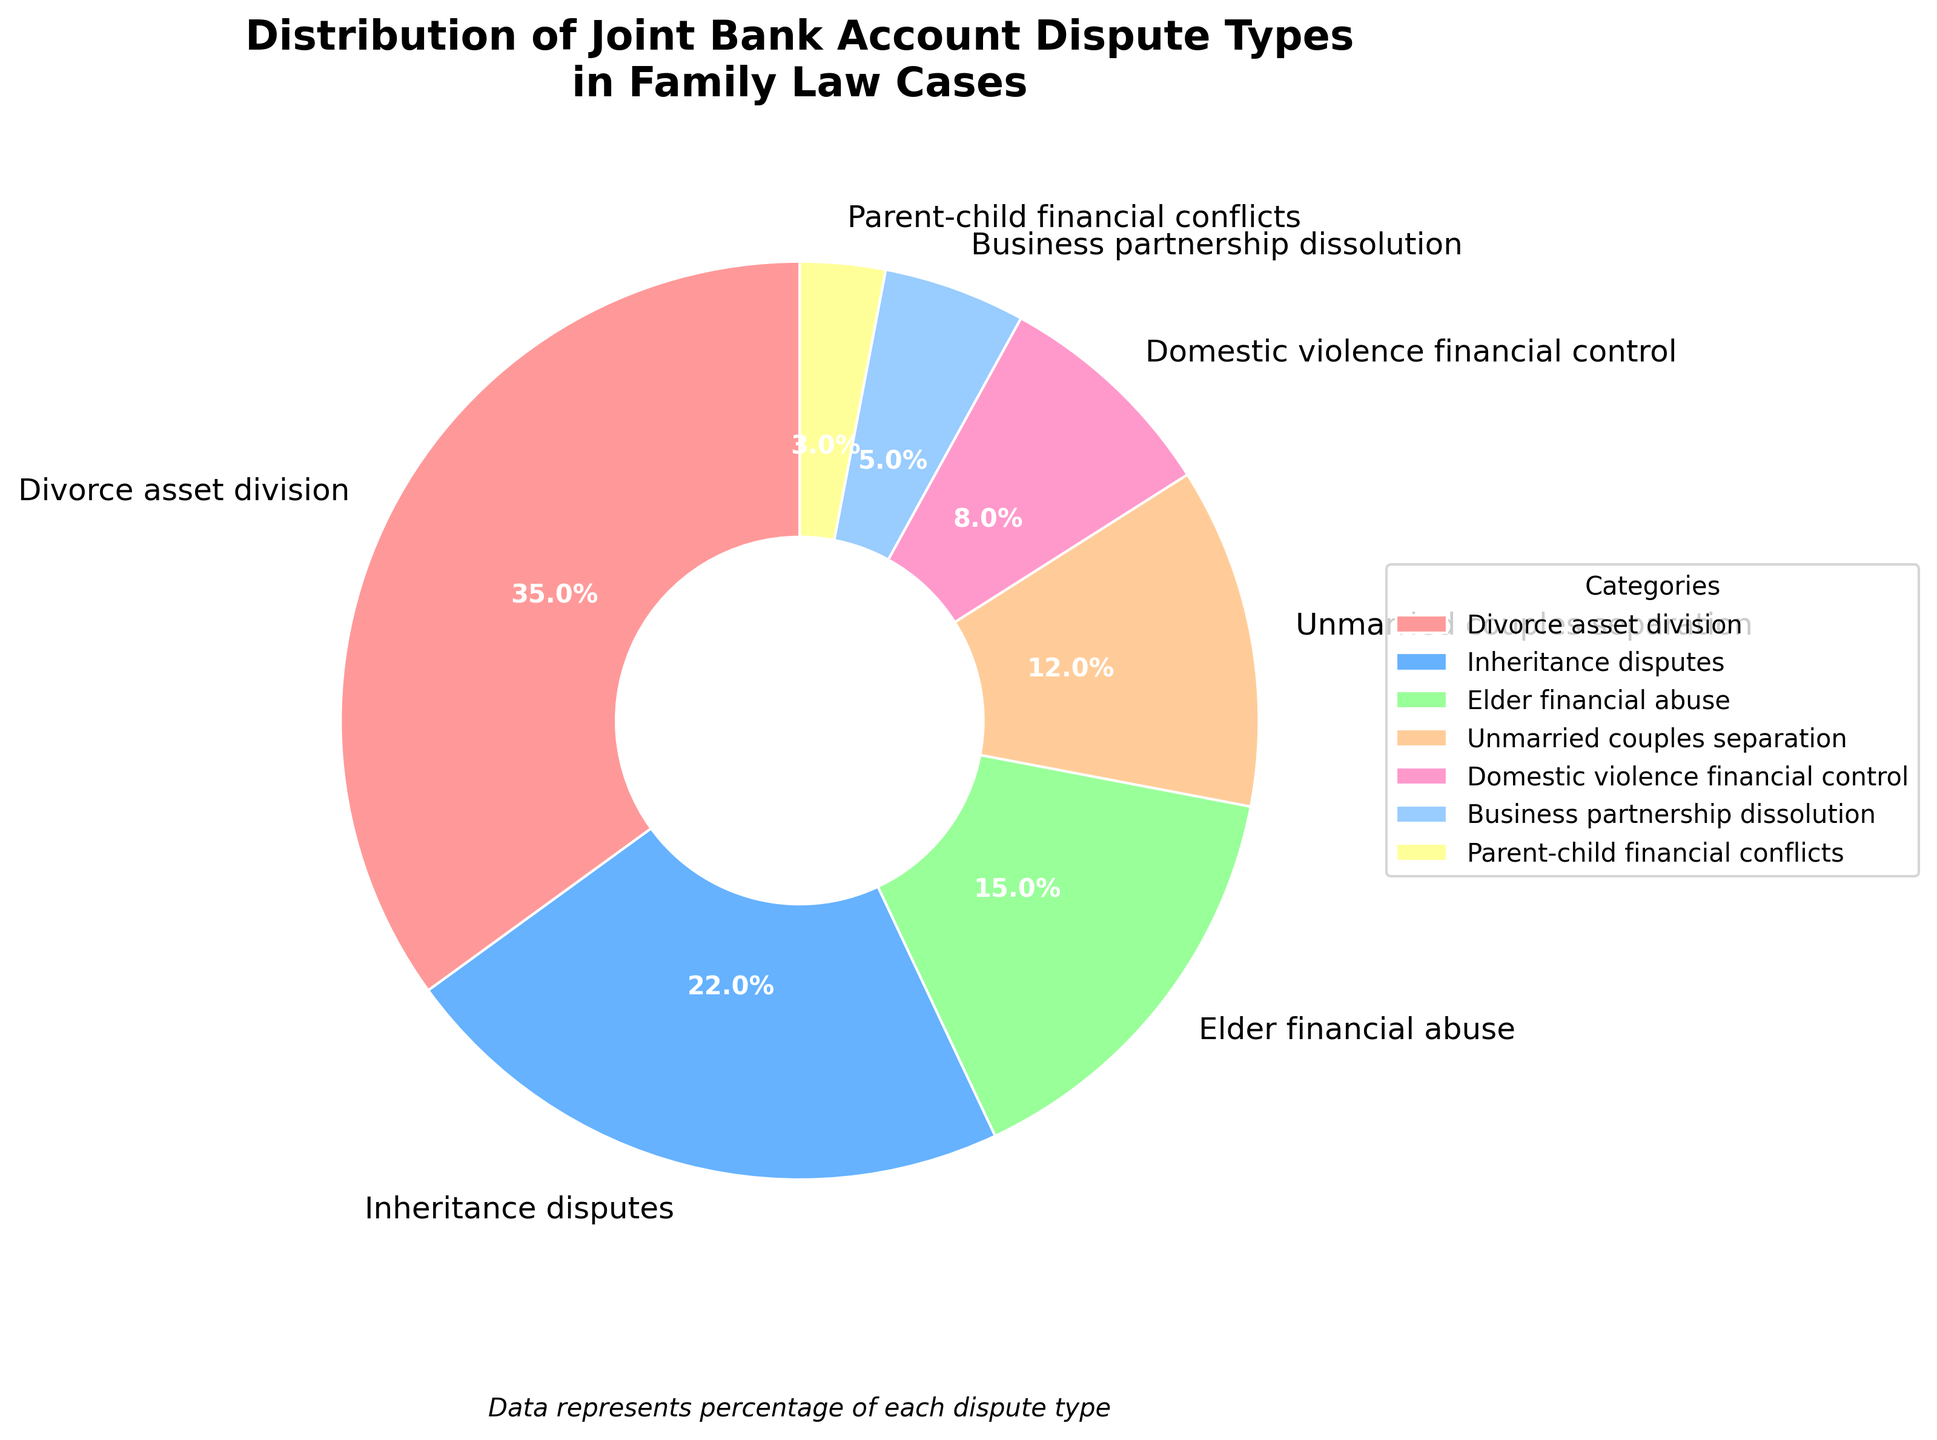What's the largest category in the distribution of joint bank account disputes? The largest category is identified by the highest percentage among the different types of disputes. According to the data, the category "Divorce asset division" has the highest percentage at 35%.
Answer: Divorce asset division What is the combined percentage of "Elder financial abuse" and "Unmarried couples separation"? To find the combined percentage of "Elder financial abuse" and "Unmarried couples separation," add the percentages of each category together. Elder financial abuse is at 15% and Unmarried couples separation is at 12%. Therefore, 15% + 12% = 27%.
Answer: 27% Which dispute type is depicted in blue? The color scheme used in the plot indicates that the dispute types are represented by different colors. By referring to the shades used, the blue color corresponds to "Inheritance disputes," which has a percentage of 22%.
Answer: Inheritance disputes Is the percentage of "Business partnership dissolution" greater than "Parent-child financial conflicts"? Comparing the percentages of the two categories, "Business partnership dissolution" is 5%, whereas "Parent-child financial conflicts" is 3%. Since 5% is greater than 3%, the percentage of "Business partnership dissolution" is indeed greater.
Answer: Yes What is the difference in percentage between the largest and the smallest categories? The largest category is "Divorce asset division" at 35%, and the smallest category is "Parent-child financial conflicts" at 3%. The difference is calculated by subtracting the smaller percentage from the larger percentage: 35% - 3% = 32%.
Answer: 32% Which two categories together account for more than half of the total distribution? To find two categories that together account for more than 50%, let's start by checking combinations of two. The two highest categories are "Divorce asset division" (35%) and "Inheritance disputes" (22%). Adding these two gives 35% + 22% = 57%, which is more than half.
Answer: Divorce asset division and Inheritance disputes How does the percentage of "Domestic violence financial control" compare to "Elder financial abuse"? The percentage of "Domestic violence financial control" is 8%, while "Elder financial abuse" is 15%. Comparing these, 8% is less than 15%.
Answer: Less What color represents the category with the smallest percentage? The category with the smallest percentage is "Parent-child financial conflicts" at 3%. According to the color distribution in the pie chart, this category is represented by a yellow color.
Answer: Yellow What is the sum of all the categories other than "Divorce asset division"? To find the sum of all categories except "Divorce asset division," add the percentages of the remaining categories: Inheritance disputes (22%), Elder financial abuse (15%), Unmarried couples separation (12%), Domestic violence financial control (8%), Business partnership dissolution (5%), and Parent-child financial conflicts (3%). Therefore, the sum is 22% + 15% + 12% + 8% + 5% + 3% = 65%.
Answer: 65% What is the total percentage of the three smallest categories? The three smallest categories are "Parent-child financial conflicts" (3%), "Business partnership dissolution" (5%), and "Domestic violence financial control" (8%). The total percentage is the sum of these values: 3% + 5% + 8% = 16%.
Answer: 16% 